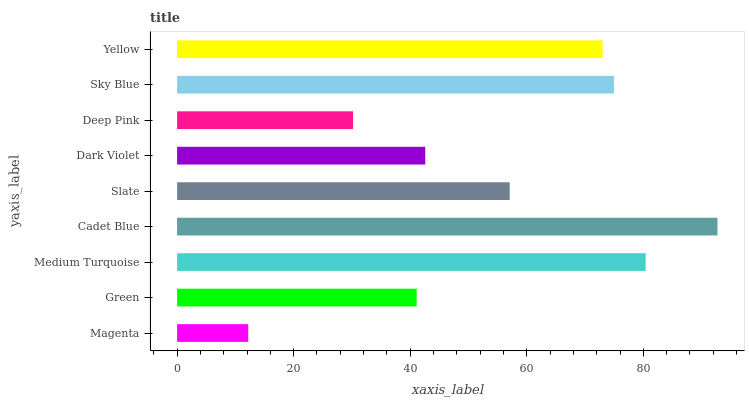Is Magenta the minimum?
Answer yes or no. Yes. Is Cadet Blue the maximum?
Answer yes or no. Yes. Is Green the minimum?
Answer yes or no. No. Is Green the maximum?
Answer yes or no. No. Is Green greater than Magenta?
Answer yes or no. Yes. Is Magenta less than Green?
Answer yes or no. Yes. Is Magenta greater than Green?
Answer yes or no. No. Is Green less than Magenta?
Answer yes or no. No. Is Slate the high median?
Answer yes or no. Yes. Is Slate the low median?
Answer yes or no. Yes. Is Magenta the high median?
Answer yes or no. No. Is Deep Pink the low median?
Answer yes or no. No. 